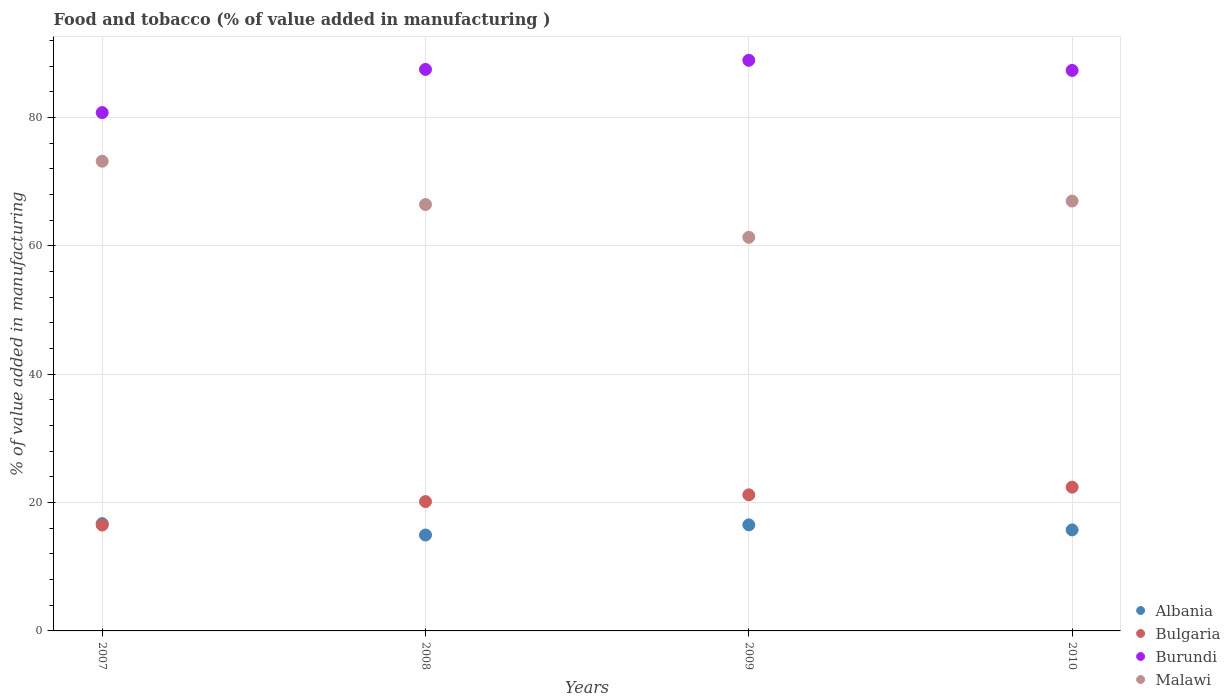Is the number of dotlines equal to the number of legend labels?
Make the answer very short. Yes. What is the value added in manufacturing food and tobacco in Albania in 2010?
Make the answer very short. 15.74. Across all years, what is the maximum value added in manufacturing food and tobacco in Bulgaria?
Offer a very short reply. 22.41. Across all years, what is the minimum value added in manufacturing food and tobacco in Albania?
Give a very brief answer. 14.95. In which year was the value added in manufacturing food and tobacco in Malawi maximum?
Your answer should be compact. 2007. What is the total value added in manufacturing food and tobacco in Bulgaria in the graph?
Ensure brevity in your answer.  80.27. What is the difference between the value added in manufacturing food and tobacco in Malawi in 2008 and that in 2010?
Make the answer very short. -0.54. What is the difference between the value added in manufacturing food and tobacco in Albania in 2008 and the value added in manufacturing food and tobacco in Bulgaria in 2007?
Ensure brevity in your answer.  -1.55. What is the average value added in manufacturing food and tobacco in Burundi per year?
Provide a succinct answer. 86.14. In the year 2007, what is the difference between the value added in manufacturing food and tobacco in Burundi and value added in manufacturing food and tobacco in Bulgaria?
Offer a terse response. 64.28. In how many years, is the value added in manufacturing food and tobacco in Burundi greater than 20 %?
Make the answer very short. 4. What is the ratio of the value added in manufacturing food and tobacco in Bulgaria in 2007 to that in 2010?
Make the answer very short. 0.74. Is the difference between the value added in manufacturing food and tobacco in Burundi in 2008 and 2009 greater than the difference between the value added in manufacturing food and tobacco in Bulgaria in 2008 and 2009?
Your response must be concise. No. What is the difference between the highest and the second highest value added in manufacturing food and tobacco in Burundi?
Ensure brevity in your answer.  1.42. What is the difference between the highest and the lowest value added in manufacturing food and tobacco in Albania?
Your answer should be compact. 1.78. Is the sum of the value added in manufacturing food and tobacco in Burundi in 2008 and 2010 greater than the maximum value added in manufacturing food and tobacco in Malawi across all years?
Your response must be concise. Yes. Is it the case that in every year, the sum of the value added in manufacturing food and tobacco in Albania and value added in manufacturing food and tobacco in Burundi  is greater than the sum of value added in manufacturing food and tobacco in Bulgaria and value added in manufacturing food and tobacco in Malawi?
Offer a very short reply. Yes. Does the value added in manufacturing food and tobacco in Bulgaria monotonically increase over the years?
Offer a terse response. Yes. Is the value added in manufacturing food and tobacco in Albania strictly greater than the value added in manufacturing food and tobacco in Malawi over the years?
Offer a very short reply. No. Is the value added in manufacturing food and tobacco in Burundi strictly less than the value added in manufacturing food and tobacco in Bulgaria over the years?
Give a very brief answer. No. How many years are there in the graph?
Make the answer very short. 4. Does the graph contain any zero values?
Ensure brevity in your answer.  No. How many legend labels are there?
Provide a short and direct response. 4. What is the title of the graph?
Your answer should be compact. Food and tobacco (% of value added in manufacturing ). Does "Morocco" appear as one of the legend labels in the graph?
Your answer should be very brief. No. What is the label or title of the X-axis?
Give a very brief answer. Years. What is the label or title of the Y-axis?
Offer a terse response. % of value added in manufacturing. What is the % of value added in manufacturing in Albania in 2007?
Provide a short and direct response. 16.72. What is the % of value added in manufacturing in Bulgaria in 2007?
Ensure brevity in your answer.  16.5. What is the % of value added in manufacturing of Burundi in 2007?
Your answer should be compact. 80.78. What is the % of value added in manufacturing of Malawi in 2007?
Your response must be concise. 73.2. What is the % of value added in manufacturing in Albania in 2008?
Offer a terse response. 14.95. What is the % of value added in manufacturing of Bulgaria in 2008?
Your answer should be very brief. 20.16. What is the % of value added in manufacturing of Burundi in 2008?
Provide a short and direct response. 87.5. What is the % of value added in manufacturing of Malawi in 2008?
Ensure brevity in your answer.  66.45. What is the % of value added in manufacturing of Albania in 2009?
Provide a succinct answer. 16.53. What is the % of value added in manufacturing in Bulgaria in 2009?
Provide a succinct answer. 21.21. What is the % of value added in manufacturing of Burundi in 2009?
Your response must be concise. 88.92. What is the % of value added in manufacturing of Malawi in 2009?
Your answer should be very brief. 61.34. What is the % of value added in manufacturing in Albania in 2010?
Make the answer very short. 15.74. What is the % of value added in manufacturing in Bulgaria in 2010?
Ensure brevity in your answer.  22.41. What is the % of value added in manufacturing of Burundi in 2010?
Your answer should be compact. 87.35. What is the % of value added in manufacturing in Malawi in 2010?
Provide a short and direct response. 66.99. Across all years, what is the maximum % of value added in manufacturing of Albania?
Make the answer very short. 16.72. Across all years, what is the maximum % of value added in manufacturing of Bulgaria?
Your response must be concise. 22.41. Across all years, what is the maximum % of value added in manufacturing in Burundi?
Keep it short and to the point. 88.92. Across all years, what is the maximum % of value added in manufacturing in Malawi?
Keep it short and to the point. 73.2. Across all years, what is the minimum % of value added in manufacturing in Albania?
Provide a short and direct response. 14.95. Across all years, what is the minimum % of value added in manufacturing in Bulgaria?
Provide a short and direct response. 16.5. Across all years, what is the minimum % of value added in manufacturing of Burundi?
Keep it short and to the point. 80.78. Across all years, what is the minimum % of value added in manufacturing of Malawi?
Give a very brief answer. 61.34. What is the total % of value added in manufacturing in Albania in the graph?
Ensure brevity in your answer.  63.94. What is the total % of value added in manufacturing in Bulgaria in the graph?
Ensure brevity in your answer.  80.27. What is the total % of value added in manufacturing in Burundi in the graph?
Make the answer very short. 344.55. What is the total % of value added in manufacturing in Malawi in the graph?
Keep it short and to the point. 267.97. What is the difference between the % of value added in manufacturing in Albania in 2007 and that in 2008?
Make the answer very short. 1.78. What is the difference between the % of value added in manufacturing of Bulgaria in 2007 and that in 2008?
Keep it short and to the point. -3.66. What is the difference between the % of value added in manufacturing of Burundi in 2007 and that in 2008?
Make the answer very short. -6.73. What is the difference between the % of value added in manufacturing of Malawi in 2007 and that in 2008?
Make the answer very short. 6.75. What is the difference between the % of value added in manufacturing of Albania in 2007 and that in 2009?
Your response must be concise. 0.19. What is the difference between the % of value added in manufacturing of Bulgaria in 2007 and that in 2009?
Keep it short and to the point. -4.71. What is the difference between the % of value added in manufacturing in Burundi in 2007 and that in 2009?
Provide a succinct answer. -8.15. What is the difference between the % of value added in manufacturing of Malawi in 2007 and that in 2009?
Keep it short and to the point. 11.86. What is the difference between the % of value added in manufacturing in Albania in 2007 and that in 2010?
Give a very brief answer. 0.98. What is the difference between the % of value added in manufacturing of Bulgaria in 2007 and that in 2010?
Your answer should be very brief. -5.91. What is the difference between the % of value added in manufacturing of Burundi in 2007 and that in 2010?
Keep it short and to the point. -6.57. What is the difference between the % of value added in manufacturing of Malawi in 2007 and that in 2010?
Offer a very short reply. 6.21. What is the difference between the % of value added in manufacturing in Albania in 2008 and that in 2009?
Your response must be concise. -1.59. What is the difference between the % of value added in manufacturing in Bulgaria in 2008 and that in 2009?
Your answer should be very brief. -1.05. What is the difference between the % of value added in manufacturing of Burundi in 2008 and that in 2009?
Provide a short and direct response. -1.42. What is the difference between the % of value added in manufacturing in Malawi in 2008 and that in 2009?
Give a very brief answer. 5.11. What is the difference between the % of value added in manufacturing in Albania in 2008 and that in 2010?
Give a very brief answer. -0.8. What is the difference between the % of value added in manufacturing of Bulgaria in 2008 and that in 2010?
Provide a short and direct response. -2.25. What is the difference between the % of value added in manufacturing in Burundi in 2008 and that in 2010?
Provide a succinct answer. 0.16. What is the difference between the % of value added in manufacturing in Malawi in 2008 and that in 2010?
Ensure brevity in your answer.  -0.54. What is the difference between the % of value added in manufacturing in Albania in 2009 and that in 2010?
Ensure brevity in your answer.  0.79. What is the difference between the % of value added in manufacturing of Bulgaria in 2009 and that in 2010?
Offer a terse response. -1.2. What is the difference between the % of value added in manufacturing of Burundi in 2009 and that in 2010?
Give a very brief answer. 1.58. What is the difference between the % of value added in manufacturing in Malawi in 2009 and that in 2010?
Make the answer very short. -5.65. What is the difference between the % of value added in manufacturing in Albania in 2007 and the % of value added in manufacturing in Bulgaria in 2008?
Offer a very short reply. -3.44. What is the difference between the % of value added in manufacturing in Albania in 2007 and the % of value added in manufacturing in Burundi in 2008?
Make the answer very short. -70.78. What is the difference between the % of value added in manufacturing of Albania in 2007 and the % of value added in manufacturing of Malawi in 2008?
Your answer should be compact. -49.72. What is the difference between the % of value added in manufacturing of Bulgaria in 2007 and the % of value added in manufacturing of Burundi in 2008?
Offer a very short reply. -71. What is the difference between the % of value added in manufacturing of Bulgaria in 2007 and the % of value added in manufacturing of Malawi in 2008?
Your answer should be compact. -49.95. What is the difference between the % of value added in manufacturing in Burundi in 2007 and the % of value added in manufacturing in Malawi in 2008?
Keep it short and to the point. 14.33. What is the difference between the % of value added in manufacturing of Albania in 2007 and the % of value added in manufacturing of Bulgaria in 2009?
Make the answer very short. -4.49. What is the difference between the % of value added in manufacturing in Albania in 2007 and the % of value added in manufacturing in Burundi in 2009?
Offer a terse response. -72.2. What is the difference between the % of value added in manufacturing of Albania in 2007 and the % of value added in manufacturing of Malawi in 2009?
Provide a short and direct response. -44.62. What is the difference between the % of value added in manufacturing in Bulgaria in 2007 and the % of value added in manufacturing in Burundi in 2009?
Ensure brevity in your answer.  -72.42. What is the difference between the % of value added in manufacturing in Bulgaria in 2007 and the % of value added in manufacturing in Malawi in 2009?
Ensure brevity in your answer.  -44.84. What is the difference between the % of value added in manufacturing in Burundi in 2007 and the % of value added in manufacturing in Malawi in 2009?
Your response must be concise. 19.44. What is the difference between the % of value added in manufacturing in Albania in 2007 and the % of value added in manufacturing in Bulgaria in 2010?
Provide a short and direct response. -5.68. What is the difference between the % of value added in manufacturing in Albania in 2007 and the % of value added in manufacturing in Burundi in 2010?
Ensure brevity in your answer.  -70.63. What is the difference between the % of value added in manufacturing in Albania in 2007 and the % of value added in manufacturing in Malawi in 2010?
Your answer should be very brief. -50.27. What is the difference between the % of value added in manufacturing in Bulgaria in 2007 and the % of value added in manufacturing in Burundi in 2010?
Provide a short and direct response. -70.85. What is the difference between the % of value added in manufacturing in Bulgaria in 2007 and the % of value added in manufacturing in Malawi in 2010?
Offer a very short reply. -50.49. What is the difference between the % of value added in manufacturing in Burundi in 2007 and the % of value added in manufacturing in Malawi in 2010?
Keep it short and to the point. 13.79. What is the difference between the % of value added in manufacturing of Albania in 2008 and the % of value added in manufacturing of Bulgaria in 2009?
Your answer should be compact. -6.26. What is the difference between the % of value added in manufacturing in Albania in 2008 and the % of value added in manufacturing in Burundi in 2009?
Make the answer very short. -73.98. What is the difference between the % of value added in manufacturing in Albania in 2008 and the % of value added in manufacturing in Malawi in 2009?
Provide a short and direct response. -46.39. What is the difference between the % of value added in manufacturing of Bulgaria in 2008 and the % of value added in manufacturing of Burundi in 2009?
Make the answer very short. -68.77. What is the difference between the % of value added in manufacturing of Bulgaria in 2008 and the % of value added in manufacturing of Malawi in 2009?
Provide a succinct answer. -41.18. What is the difference between the % of value added in manufacturing in Burundi in 2008 and the % of value added in manufacturing in Malawi in 2009?
Offer a very short reply. 26.16. What is the difference between the % of value added in manufacturing in Albania in 2008 and the % of value added in manufacturing in Bulgaria in 2010?
Make the answer very short. -7.46. What is the difference between the % of value added in manufacturing of Albania in 2008 and the % of value added in manufacturing of Burundi in 2010?
Ensure brevity in your answer.  -72.4. What is the difference between the % of value added in manufacturing in Albania in 2008 and the % of value added in manufacturing in Malawi in 2010?
Provide a succinct answer. -52.04. What is the difference between the % of value added in manufacturing in Bulgaria in 2008 and the % of value added in manufacturing in Burundi in 2010?
Offer a very short reply. -67.19. What is the difference between the % of value added in manufacturing in Bulgaria in 2008 and the % of value added in manufacturing in Malawi in 2010?
Keep it short and to the point. -46.83. What is the difference between the % of value added in manufacturing of Burundi in 2008 and the % of value added in manufacturing of Malawi in 2010?
Ensure brevity in your answer.  20.51. What is the difference between the % of value added in manufacturing in Albania in 2009 and the % of value added in manufacturing in Bulgaria in 2010?
Provide a succinct answer. -5.87. What is the difference between the % of value added in manufacturing of Albania in 2009 and the % of value added in manufacturing of Burundi in 2010?
Make the answer very short. -70.81. What is the difference between the % of value added in manufacturing of Albania in 2009 and the % of value added in manufacturing of Malawi in 2010?
Make the answer very short. -50.46. What is the difference between the % of value added in manufacturing in Bulgaria in 2009 and the % of value added in manufacturing in Burundi in 2010?
Provide a short and direct response. -66.14. What is the difference between the % of value added in manufacturing in Bulgaria in 2009 and the % of value added in manufacturing in Malawi in 2010?
Provide a succinct answer. -45.78. What is the difference between the % of value added in manufacturing in Burundi in 2009 and the % of value added in manufacturing in Malawi in 2010?
Provide a short and direct response. 21.93. What is the average % of value added in manufacturing of Albania per year?
Give a very brief answer. 15.99. What is the average % of value added in manufacturing in Bulgaria per year?
Offer a very short reply. 20.07. What is the average % of value added in manufacturing of Burundi per year?
Offer a very short reply. 86.14. What is the average % of value added in manufacturing of Malawi per year?
Provide a succinct answer. 66.99. In the year 2007, what is the difference between the % of value added in manufacturing of Albania and % of value added in manufacturing of Bulgaria?
Your response must be concise. 0.22. In the year 2007, what is the difference between the % of value added in manufacturing of Albania and % of value added in manufacturing of Burundi?
Give a very brief answer. -64.05. In the year 2007, what is the difference between the % of value added in manufacturing of Albania and % of value added in manufacturing of Malawi?
Your answer should be compact. -56.48. In the year 2007, what is the difference between the % of value added in manufacturing in Bulgaria and % of value added in manufacturing in Burundi?
Make the answer very short. -64.28. In the year 2007, what is the difference between the % of value added in manufacturing of Bulgaria and % of value added in manufacturing of Malawi?
Your answer should be compact. -56.7. In the year 2007, what is the difference between the % of value added in manufacturing in Burundi and % of value added in manufacturing in Malawi?
Provide a short and direct response. 7.58. In the year 2008, what is the difference between the % of value added in manufacturing in Albania and % of value added in manufacturing in Bulgaria?
Make the answer very short. -5.21. In the year 2008, what is the difference between the % of value added in manufacturing of Albania and % of value added in manufacturing of Burundi?
Make the answer very short. -72.56. In the year 2008, what is the difference between the % of value added in manufacturing of Albania and % of value added in manufacturing of Malawi?
Keep it short and to the point. -51.5. In the year 2008, what is the difference between the % of value added in manufacturing of Bulgaria and % of value added in manufacturing of Burundi?
Your response must be concise. -67.35. In the year 2008, what is the difference between the % of value added in manufacturing in Bulgaria and % of value added in manufacturing in Malawi?
Your answer should be compact. -46.29. In the year 2008, what is the difference between the % of value added in manufacturing of Burundi and % of value added in manufacturing of Malawi?
Provide a short and direct response. 21.06. In the year 2009, what is the difference between the % of value added in manufacturing in Albania and % of value added in manufacturing in Bulgaria?
Make the answer very short. -4.68. In the year 2009, what is the difference between the % of value added in manufacturing in Albania and % of value added in manufacturing in Burundi?
Make the answer very short. -72.39. In the year 2009, what is the difference between the % of value added in manufacturing of Albania and % of value added in manufacturing of Malawi?
Keep it short and to the point. -44.81. In the year 2009, what is the difference between the % of value added in manufacturing of Bulgaria and % of value added in manufacturing of Burundi?
Provide a succinct answer. -67.71. In the year 2009, what is the difference between the % of value added in manufacturing of Bulgaria and % of value added in manufacturing of Malawi?
Offer a terse response. -40.13. In the year 2009, what is the difference between the % of value added in manufacturing in Burundi and % of value added in manufacturing in Malawi?
Offer a terse response. 27.58. In the year 2010, what is the difference between the % of value added in manufacturing of Albania and % of value added in manufacturing of Bulgaria?
Provide a short and direct response. -6.66. In the year 2010, what is the difference between the % of value added in manufacturing of Albania and % of value added in manufacturing of Burundi?
Provide a succinct answer. -71.6. In the year 2010, what is the difference between the % of value added in manufacturing in Albania and % of value added in manufacturing in Malawi?
Ensure brevity in your answer.  -51.25. In the year 2010, what is the difference between the % of value added in manufacturing of Bulgaria and % of value added in manufacturing of Burundi?
Offer a very short reply. -64.94. In the year 2010, what is the difference between the % of value added in manufacturing in Bulgaria and % of value added in manufacturing in Malawi?
Your answer should be very brief. -44.58. In the year 2010, what is the difference between the % of value added in manufacturing in Burundi and % of value added in manufacturing in Malawi?
Provide a succinct answer. 20.36. What is the ratio of the % of value added in manufacturing of Albania in 2007 to that in 2008?
Offer a terse response. 1.12. What is the ratio of the % of value added in manufacturing in Bulgaria in 2007 to that in 2008?
Provide a succinct answer. 0.82. What is the ratio of the % of value added in manufacturing of Malawi in 2007 to that in 2008?
Your answer should be very brief. 1.1. What is the ratio of the % of value added in manufacturing in Albania in 2007 to that in 2009?
Ensure brevity in your answer.  1.01. What is the ratio of the % of value added in manufacturing in Bulgaria in 2007 to that in 2009?
Your response must be concise. 0.78. What is the ratio of the % of value added in manufacturing in Burundi in 2007 to that in 2009?
Provide a succinct answer. 0.91. What is the ratio of the % of value added in manufacturing in Malawi in 2007 to that in 2009?
Keep it short and to the point. 1.19. What is the ratio of the % of value added in manufacturing of Albania in 2007 to that in 2010?
Ensure brevity in your answer.  1.06. What is the ratio of the % of value added in manufacturing in Bulgaria in 2007 to that in 2010?
Make the answer very short. 0.74. What is the ratio of the % of value added in manufacturing in Burundi in 2007 to that in 2010?
Give a very brief answer. 0.92. What is the ratio of the % of value added in manufacturing in Malawi in 2007 to that in 2010?
Offer a terse response. 1.09. What is the ratio of the % of value added in manufacturing of Albania in 2008 to that in 2009?
Provide a succinct answer. 0.9. What is the ratio of the % of value added in manufacturing in Bulgaria in 2008 to that in 2009?
Provide a short and direct response. 0.95. What is the ratio of the % of value added in manufacturing of Burundi in 2008 to that in 2009?
Your answer should be compact. 0.98. What is the ratio of the % of value added in manufacturing in Malawi in 2008 to that in 2009?
Offer a very short reply. 1.08. What is the ratio of the % of value added in manufacturing in Albania in 2008 to that in 2010?
Provide a succinct answer. 0.95. What is the ratio of the % of value added in manufacturing in Bulgaria in 2008 to that in 2010?
Offer a very short reply. 0.9. What is the ratio of the % of value added in manufacturing of Burundi in 2008 to that in 2010?
Ensure brevity in your answer.  1. What is the ratio of the % of value added in manufacturing in Malawi in 2008 to that in 2010?
Provide a succinct answer. 0.99. What is the ratio of the % of value added in manufacturing in Albania in 2009 to that in 2010?
Keep it short and to the point. 1.05. What is the ratio of the % of value added in manufacturing of Bulgaria in 2009 to that in 2010?
Give a very brief answer. 0.95. What is the ratio of the % of value added in manufacturing in Malawi in 2009 to that in 2010?
Keep it short and to the point. 0.92. What is the difference between the highest and the second highest % of value added in manufacturing of Albania?
Your answer should be compact. 0.19. What is the difference between the highest and the second highest % of value added in manufacturing of Bulgaria?
Your response must be concise. 1.2. What is the difference between the highest and the second highest % of value added in manufacturing of Burundi?
Provide a short and direct response. 1.42. What is the difference between the highest and the second highest % of value added in manufacturing of Malawi?
Your answer should be very brief. 6.21. What is the difference between the highest and the lowest % of value added in manufacturing in Albania?
Your answer should be compact. 1.78. What is the difference between the highest and the lowest % of value added in manufacturing in Bulgaria?
Your response must be concise. 5.91. What is the difference between the highest and the lowest % of value added in manufacturing in Burundi?
Provide a succinct answer. 8.15. What is the difference between the highest and the lowest % of value added in manufacturing in Malawi?
Provide a succinct answer. 11.86. 